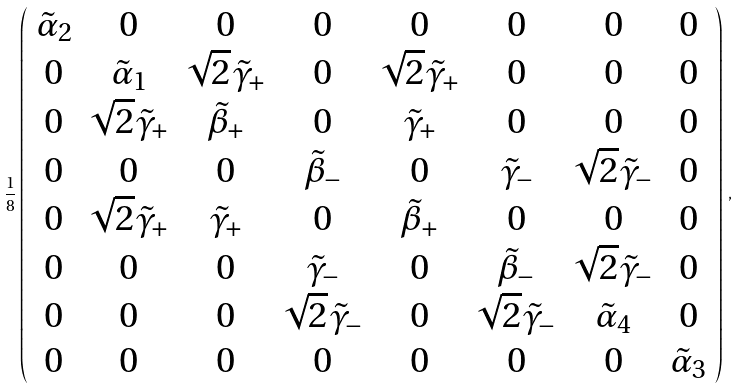Convert formula to latex. <formula><loc_0><loc_0><loc_500><loc_500>\frac { 1 } { 8 } \left ( \begin{array} { c c c c c c c c } \tilde { \alpha } _ { 2 } & 0 & 0 & 0 & 0 & 0 & 0 & 0 \\ 0 & \tilde { \alpha } _ { 1 } & \sqrt { 2 } \tilde { \gamma } _ { + } & 0 & \sqrt { 2 } \tilde { \gamma } _ { + } & 0 & 0 & 0 \\ 0 & \sqrt { 2 } \tilde { \gamma } _ { + } & \tilde { \beta } _ { + } & 0 & \tilde { \gamma } _ { + } & 0 & 0 & 0 \\ 0 & 0 & 0 & \tilde { \beta } _ { - } & 0 & \tilde { \gamma } _ { - } & \sqrt { 2 } \tilde { \gamma } _ { - } & 0 \\ 0 & \sqrt { 2 } \tilde { \gamma } _ { + } & \tilde { \gamma } _ { + } & 0 & \tilde { \beta } _ { + } & 0 & 0 & 0 \\ 0 & 0 & 0 & \tilde { \gamma } _ { - } & 0 & \tilde { \beta } _ { - } & \sqrt { 2 } \tilde { \gamma } _ { - } & 0 \\ 0 & 0 & 0 & \sqrt { 2 } \tilde { \gamma } _ { - } & 0 & \sqrt { 2 } \tilde { \gamma } _ { - } & \tilde { \alpha } _ { 4 } & 0 \\ 0 & 0 & 0 & 0 & 0 & 0 & 0 & \tilde { \alpha } _ { 3 } \\ \end{array} \right ) \, ,</formula> 